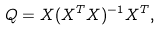Convert formula to latex. <formula><loc_0><loc_0><loc_500><loc_500>Q = X ( X ^ { T } X ) ^ { - 1 } X ^ { T } ,</formula> 